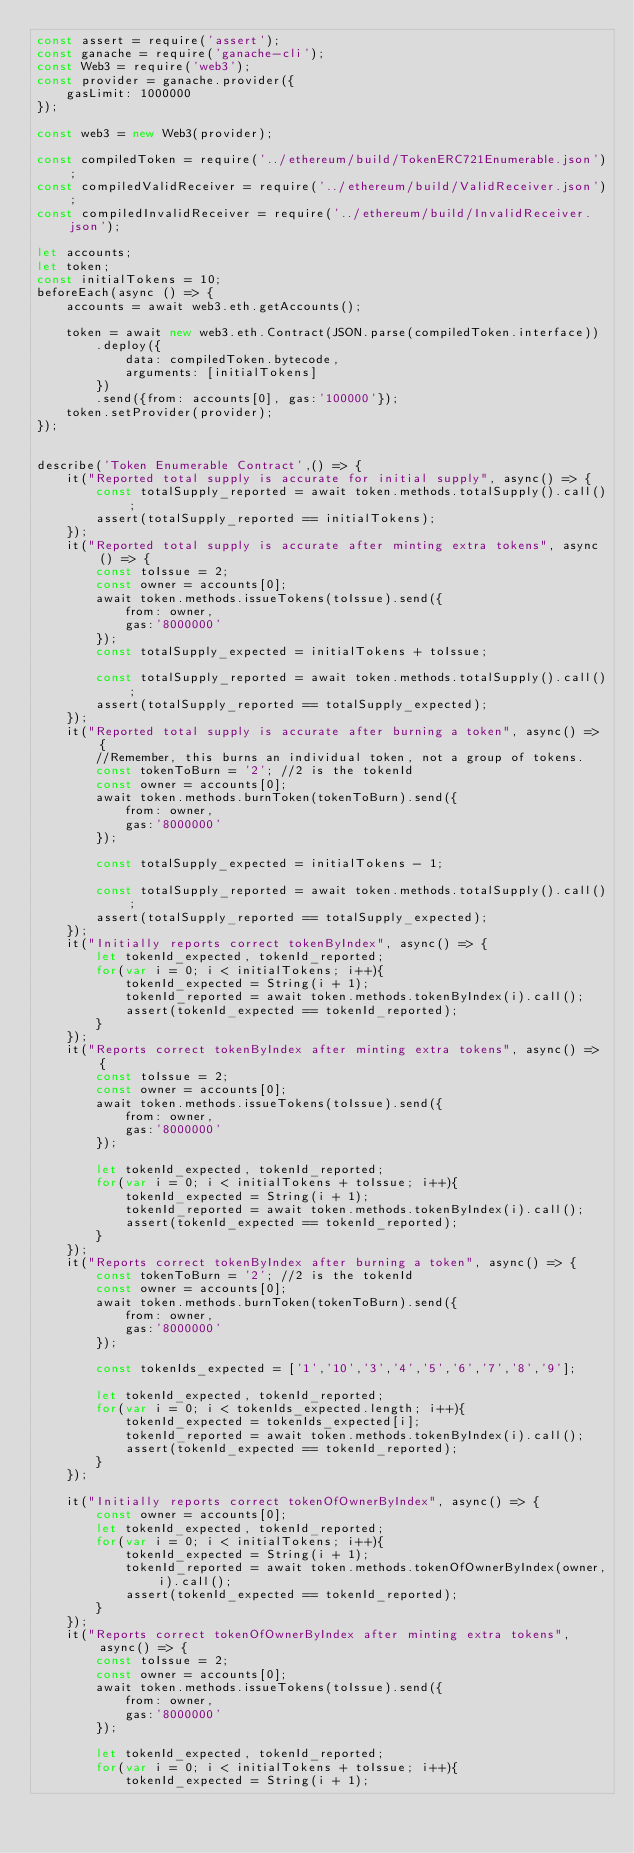Convert code to text. <code><loc_0><loc_0><loc_500><loc_500><_JavaScript_>const assert = require('assert');
const ganache = require('ganache-cli');
const Web3 = require('web3');
const provider = ganache.provider({
    gasLimit: 1000000
});

const web3 = new Web3(provider);

const compiledToken = require('../ethereum/build/TokenERC721Enumerable.json');
const compiledValidReceiver = require('../ethereum/build/ValidReceiver.json');
const compiledInvalidReceiver = require('../ethereum/build/InvalidReceiver.json');

let accounts;
let token;
const initialTokens = 10;
beforeEach(async () => {
    accounts = await web3.eth.getAccounts();

    token = await new web3.eth.Contract(JSON.parse(compiledToken.interface))
        .deploy({
            data: compiledToken.bytecode,
            arguments: [initialTokens]
        })
        .send({from: accounts[0], gas:'100000'});
    token.setProvider(provider);
});


describe('Token Enumerable Contract',() => {
    it("Reported total supply is accurate for initial supply", async() => {
        const totalSupply_reported = await token.methods.totalSupply().call();
        assert(totalSupply_reported == initialTokens);
    });
    it("Reported total supply is accurate after minting extra tokens", async() => {
        const toIssue = 2;
        const owner = accounts[0];
        await token.methods.issueTokens(toIssue).send({
            from: owner,
            gas:'8000000'
        });
        const totalSupply_expected = initialTokens + toIssue;

        const totalSupply_reported = await token.methods.totalSupply().call();
        assert(totalSupply_reported == totalSupply_expected);
    });
    it("Reported total supply is accurate after burning a token", async() => {
        //Remember, this burns an individual token, not a group of tokens.
        const tokenToBurn = '2'; //2 is the tokenId
        const owner = accounts[0];
        await token.methods.burnToken(tokenToBurn).send({
            from: owner,
            gas:'8000000'
        });

        const totalSupply_expected = initialTokens - 1;

        const totalSupply_reported = await token.methods.totalSupply().call();
        assert(totalSupply_reported == totalSupply_expected);
    });
    it("Initially reports correct tokenByIndex", async() => {
        let tokenId_expected, tokenId_reported;
        for(var i = 0; i < initialTokens; i++){
            tokenId_expected = String(i + 1);
            tokenId_reported = await token.methods.tokenByIndex(i).call();
            assert(tokenId_expected == tokenId_reported);
        }
    });
    it("Reports correct tokenByIndex after minting extra tokens", async() => {
        const toIssue = 2;
        const owner = accounts[0];
        await token.methods.issueTokens(toIssue).send({
            from: owner,
            gas:'8000000'
        });

        let tokenId_expected, tokenId_reported;
        for(var i = 0; i < initialTokens + toIssue; i++){
            tokenId_expected = String(i + 1);
            tokenId_reported = await token.methods.tokenByIndex(i).call();
            assert(tokenId_expected == tokenId_reported);
        }
    });
    it("Reports correct tokenByIndex after burning a token", async() => {
        const tokenToBurn = '2'; //2 is the tokenId
        const owner = accounts[0];
        await token.methods.burnToken(tokenToBurn).send({
            from: owner,
            gas:'8000000'
        });

        const tokenIds_expected = ['1','10','3','4','5','6','7','8','9'];

        let tokenId_expected, tokenId_reported;
        for(var i = 0; i < tokenIds_expected.length; i++){
            tokenId_expected = tokenIds_expected[i];
            tokenId_reported = await token.methods.tokenByIndex(i).call();
            assert(tokenId_expected == tokenId_reported);
        }
    });

    it("Initially reports correct tokenOfOwnerByIndex", async() => {
        const owner = accounts[0];
        let tokenId_expected, tokenId_reported;
        for(var i = 0; i < initialTokens; i++){
            tokenId_expected = String(i + 1);
            tokenId_reported = await token.methods.tokenOfOwnerByIndex(owner,i).call();
            assert(tokenId_expected == tokenId_reported);
        }
    });
    it("Reports correct tokenOfOwnerByIndex after minting extra tokens", async() => {
        const toIssue = 2;
        const owner = accounts[0];
        await token.methods.issueTokens(toIssue).send({
            from: owner,
            gas:'8000000'
        });

        let tokenId_expected, tokenId_reported;
        for(var i = 0; i < initialTokens + toIssue; i++){
            tokenId_expected = String(i + 1);</code> 